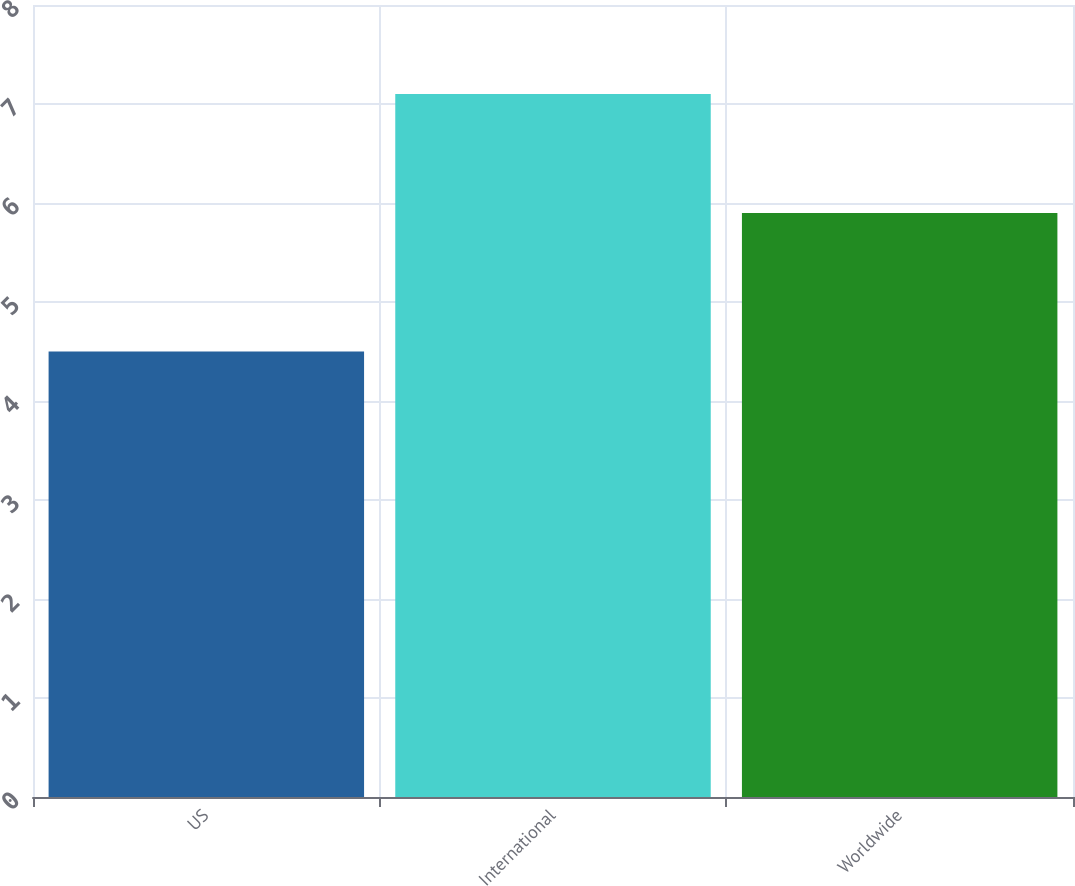Convert chart to OTSL. <chart><loc_0><loc_0><loc_500><loc_500><bar_chart><fcel>US<fcel>International<fcel>Worldwide<nl><fcel>4.5<fcel>7.1<fcel>5.9<nl></chart> 